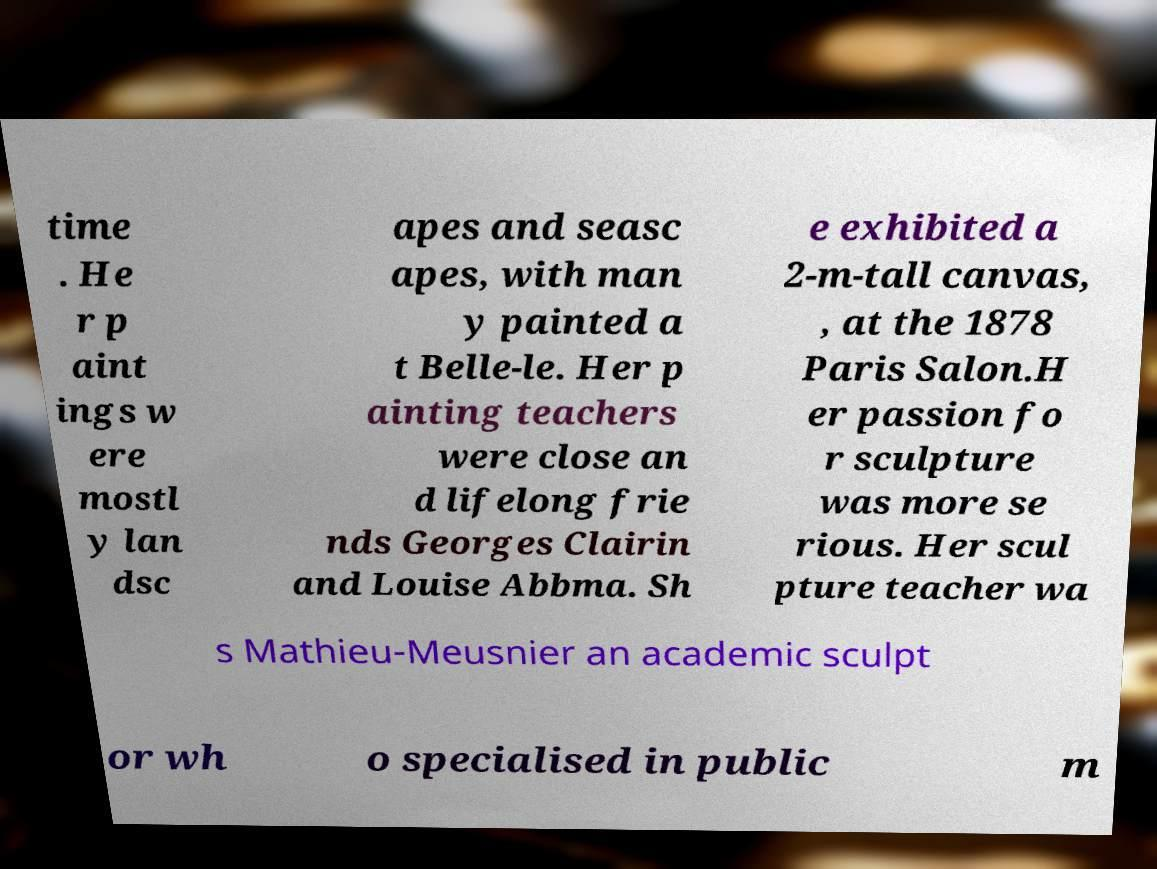Please identify and transcribe the text found in this image. time . He r p aint ings w ere mostl y lan dsc apes and seasc apes, with man y painted a t Belle-le. Her p ainting teachers were close an d lifelong frie nds Georges Clairin and Louise Abbma. Sh e exhibited a 2-m-tall canvas, , at the 1878 Paris Salon.H er passion fo r sculpture was more se rious. Her scul pture teacher wa s Mathieu-Meusnier an academic sculpt or wh o specialised in public m 